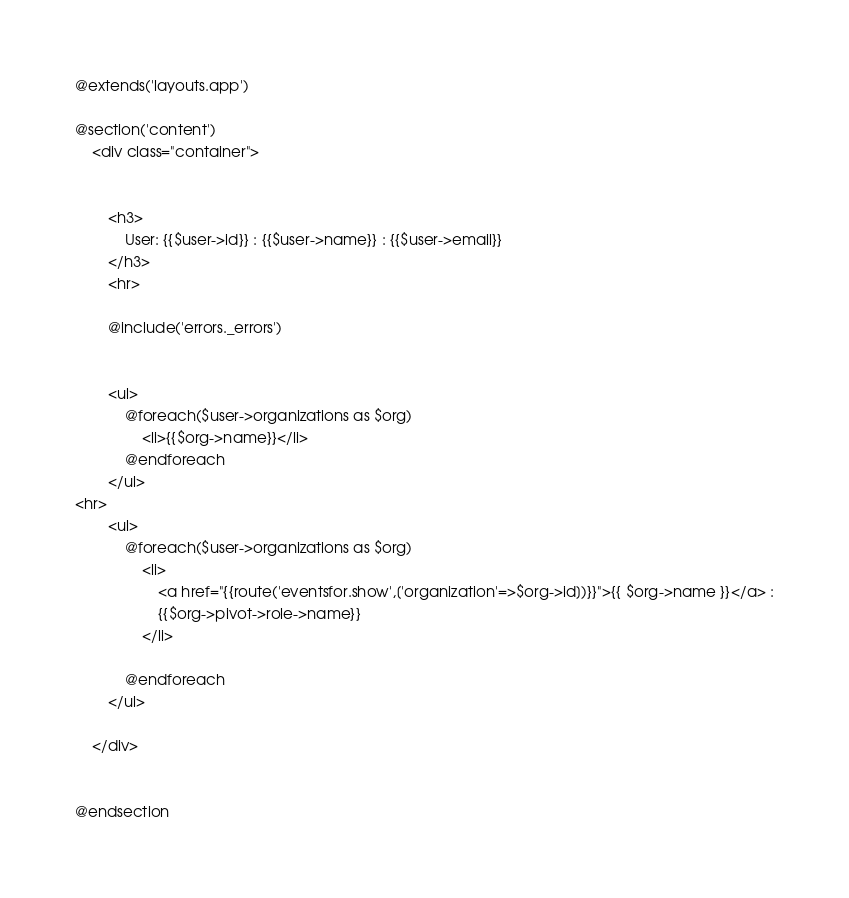<code> <loc_0><loc_0><loc_500><loc_500><_PHP_>@extends('layouts.app')

@section('content')
    <div class="container">


        <h3>
            User: {{$user->id}} : {{$user->name}} : {{$user->email}}
        </h3>
        <hr>

        @include('errors._errors')


        <ul>
            @foreach($user->organizations as $org)
                <li>{{$org->name}}</li>
            @endforeach
        </ul>
<hr>
        <ul>
            @foreach($user->organizations as $org)
                <li>
                    <a href="{{route('eventsfor.show',['organization'=>$org->id])}}">{{ $org->name }}</a> :
                    {{$org->pivot->role->name}}
                </li>

            @endforeach
        </ul>

    </div>


@endsection
</code> 